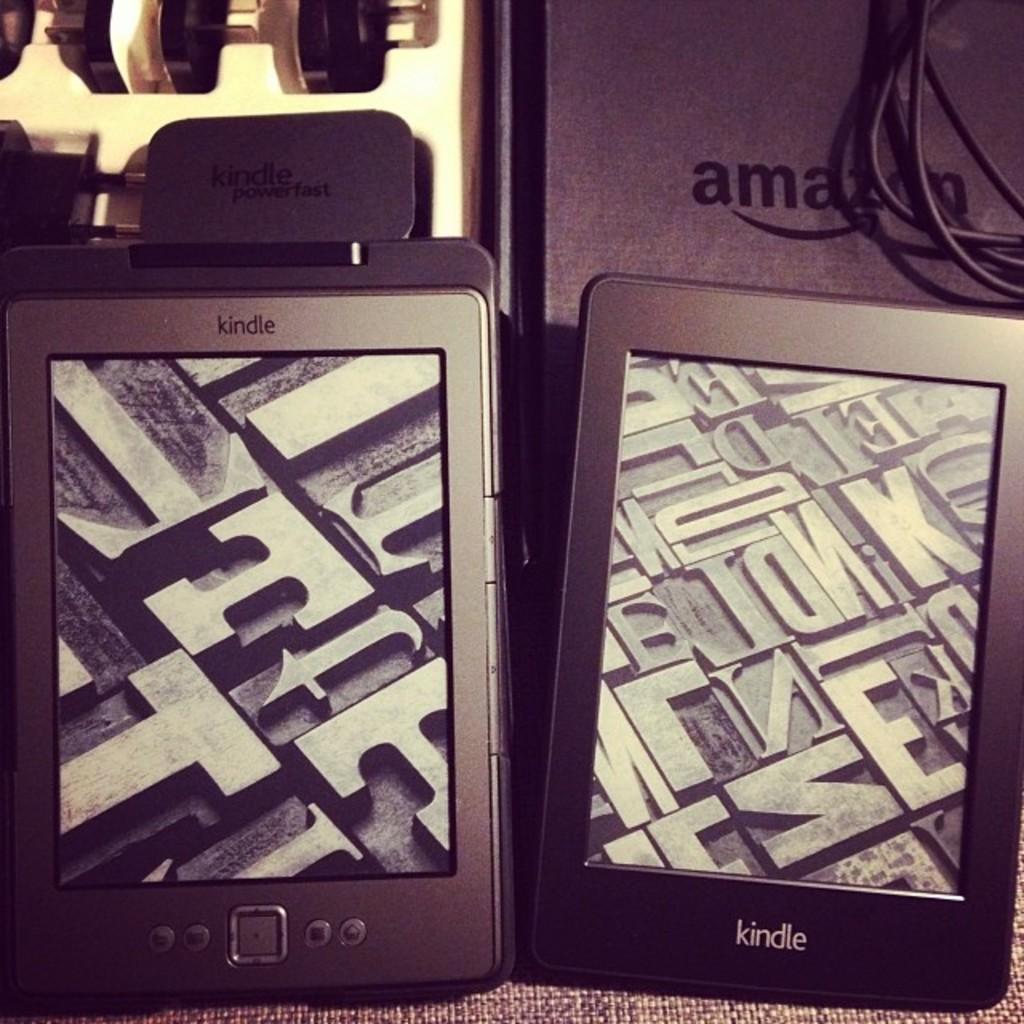What is the brand of e-reader here?
Your answer should be compact. Kindle. What company logo can you see on the top right box?
Offer a terse response. Amazon. 